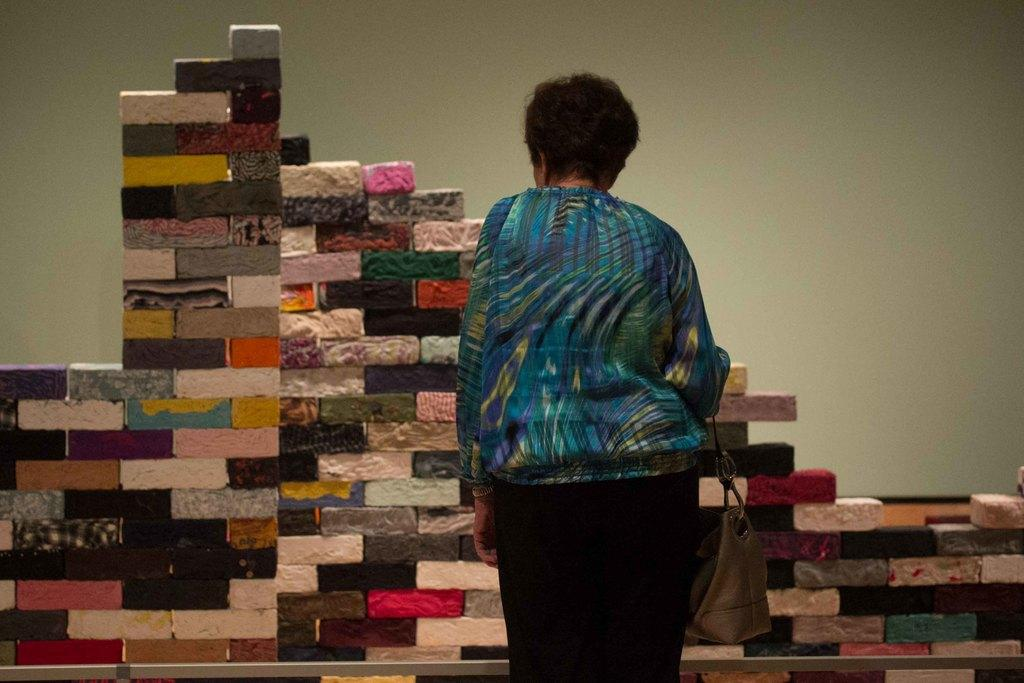Who is the main subject in the image? There is a lady in the image. What is the lady doing in the image? The lady is standing in the image. What is the lady holding in her hand? The lady is holding a bag in her hand. What can be seen in the background of the image? There are colorful bricks arranged in the background. Where are the bricks located in relation to the wall? The bricks are in front of a wall. What type of button can be seen on the lady's shirt in the image? There is no button visible on the lady's shirt in the image. What type of beef is being cooked in the background of the image? There is no beef or cooking activity present in the image; it features a lady standing with a bag and colorful bricks arranged in the background. 